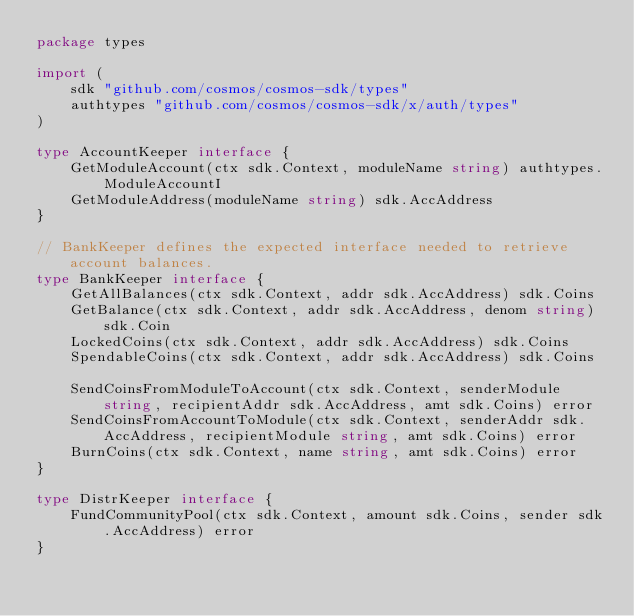Convert code to text. <code><loc_0><loc_0><loc_500><loc_500><_Go_>package types

import (
	sdk "github.com/cosmos/cosmos-sdk/types"
	authtypes "github.com/cosmos/cosmos-sdk/x/auth/types"
)

type AccountKeeper interface {
	GetModuleAccount(ctx sdk.Context, moduleName string) authtypes.ModuleAccountI
	GetModuleAddress(moduleName string) sdk.AccAddress
}

// BankKeeper defines the expected interface needed to retrieve account balances.
type BankKeeper interface {
	GetAllBalances(ctx sdk.Context, addr sdk.AccAddress) sdk.Coins
	GetBalance(ctx sdk.Context, addr sdk.AccAddress, denom string) sdk.Coin
	LockedCoins(ctx sdk.Context, addr sdk.AccAddress) sdk.Coins
	SpendableCoins(ctx sdk.Context, addr sdk.AccAddress) sdk.Coins

	SendCoinsFromModuleToAccount(ctx sdk.Context, senderModule string, recipientAddr sdk.AccAddress, amt sdk.Coins) error
	SendCoinsFromAccountToModule(ctx sdk.Context, senderAddr sdk.AccAddress, recipientModule string, amt sdk.Coins) error
	BurnCoins(ctx sdk.Context, name string, amt sdk.Coins) error
}

type DistrKeeper interface {
	FundCommunityPool(ctx sdk.Context, amount sdk.Coins, sender sdk.AccAddress) error
}
</code> 